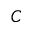Convert formula to latex. <formula><loc_0><loc_0><loc_500><loc_500>C</formula> 